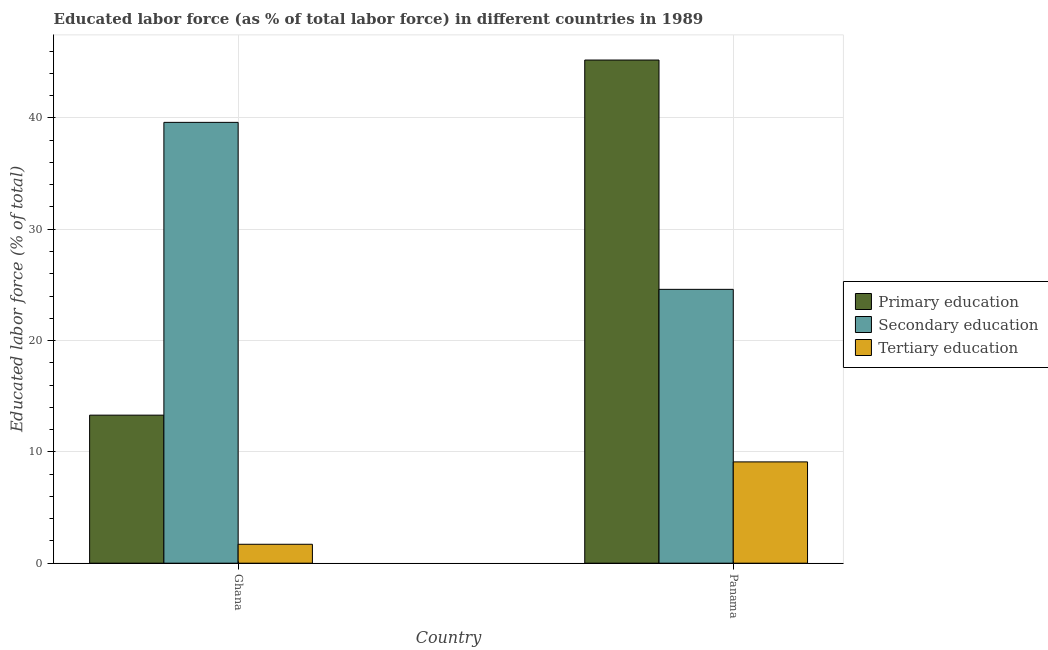How many bars are there on the 2nd tick from the right?
Give a very brief answer. 3. What is the label of the 2nd group of bars from the left?
Keep it short and to the point. Panama. In how many cases, is the number of bars for a given country not equal to the number of legend labels?
Your answer should be very brief. 0. What is the percentage of labor force who received primary education in Ghana?
Provide a short and direct response. 13.3. Across all countries, what is the maximum percentage of labor force who received primary education?
Your response must be concise. 45.2. Across all countries, what is the minimum percentage of labor force who received primary education?
Provide a succinct answer. 13.3. In which country was the percentage of labor force who received secondary education maximum?
Ensure brevity in your answer.  Ghana. In which country was the percentage of labor force who received tertiary education minimum?
Offer a terse response. Ghana. What is the total percentage of labor force who received tertiary education in the graph?
Make the answer very short. 10.8. What is the difference between the percentage of labor force who received tertiary education in Ghana and that in Panama?
Provide a short and direct response. -7.4. What is the difference between the percentage of labor force who received secondary education in Ghana and the percentage of labor force who received tertiary education in Panama?
Provide a short and direct response. 30.5. What is the average percentage of labor force who received tertiary education per country?
Provide a succinct answer. 5.4. What is the difference between the percentage of labor force who received secondary education and percentage of labor force who received tertiary education in Panama?
Give a very brief answer. 15.5. In how many countries, is the percentage of labor force who received primary education greater than 28 %?
Ensure brevity in your answer.  1. What is the ratio of the percentage of labor force who received tertiary education in Ghana to that in Panama?
Give a very brief answer. 0.19. What does the 3rd bar from the left in Ghana represents?
Provide a short and direct response. Tertiary education. How many bars are there?
Provide a succinct answer. 6. Are all the bars in the graph horizontal?
Your response must be concise. No. Are the values on the major ticks of Y-axis written in scientific E-notation?
Your answer should be compact. No. Does the graph contain any zero values?
Offer a very short reply. No. Does the graph contain grids?
Offer a very short reply. Yes. Where does the legend appear in the graph?
Offer a terse response. Center right. How many legend labels are there?
Keep it short and to the point. 3. What is the title of the graph?
Keep it short and to the point. Educated labor force (as % of total labor force) in different countries in 1989. What is the label or title of the Y-axis?
Your answer should be very brief. Educated labor force (% of total). What is the Educated labor force (% of total) of Primary education in Ghana?
Give a very brief answer. 13.3. What is the Educated labor force (% of total) of Secondary education in Ghana?
Offer a very short reply. 39.6. What is the Educated labor force (% of total) of Tertiary education in Ghana?
Make the answer very short. 1.7. What is the Educated labor force (% of total) of Primary education in Panama?
Make the answer very short. 45.2. What is the Educated labor force (% of total) of Secondary education in Panama?
Make the answer very short. 24.6. What is the Educated labor force (% of total) of Tertiary education in Panama?
Provide a short and direct response. 9.1. Across all countries, what is the maximum Educated labor force (% of total) in Primary education?
Provide a short and direct response. 45.2. Across all countries, what is the maximum Educated labor force (% of total) of Secondary education?
Provide a short and direct response. 39.6. Across all countries, what is the maximum Educated labor force (% of total) in Tertiary education?
Provide a succinct answer. 9.1. Across all countries, what is the minimum Educated labor force (% of total) in Primary education?
Make the answer very short. 13.3. Across all countries, what is the minimum Educated labor force (% of total) in Secondary education?
Offer a terse response. 24.6. Across all countries, what is the minimum Educated labor force (% of total) in Tertiary education?
Give a very brief answer. 1.7. What is the total Educated labor force (% of total) in Primary education in the graph?
Offer a terse response. 58.5. What is the total Educated labor force (% of total) of Secondary education in the graph?
Your answer should be compact. 64.2. What is the total Educated labor force (% of total) of Tertiary education in the graph?
Give a very brief answer. 10.8. What is the difference between the Educated labor force (% of total) in Primary education in Ghana and that in Panama?
Offer a terse response. -31.9. What is the difference between the Educated labor force (% of total) of Secondary education in Ghana and that in Panama?
Keep it short and to the point. 15. What is the difference between the Educated labor force (% of total) of Tertiary education in Ghana and that in Panama?
Your answer should be very brief. -7.4. What is the difference between the Educated labor force (% of total) of Primary education in Ghana and the Educated labor force (% of total) of Tertiary education in Panama?
Provide a succinct answer. 4.2. What is the difference between the Educated labor force (% of total) in Secondary education in Ghana and the Educated labor force (% of total) in Tertiary education in Panama?
Your answer should be very brief. 30.5. What is the average Educated labor force (% of total) in Primary education per country?
Ensure brevity in your answer.  29.25. What is the average Educated labor force (% of total) of Secondary education per country?
Give a very brief answer. 32.1. What is the average Educated labor force (% of total) of Tertiary education per country?
Your answer should be very brief. 5.4. What is the difference between the Educated labor force (% of total) in Primary education and Educated labor force (% of total) in Secondary education in Ghana?
Provide a short and direct response. -26.3. What is the difference between the Educated labor force (% of total) in Primary education and Educated labor force (% of total) in Tertiary education in Ghana?
Your response must be concise. 11.6. What is the difference between the Educated labor force (% of total) in Secondary education and Educated labor force (% of total) in Tertiary education in Ghana?
Offer a terse response. 37.9. What is the difference between the Educated labor force (% of total) of Primary education and Educated labor force (% of total) of Secondary education in Panama?
Make the answer very short. 20.6. What is the difference between the Educated labor force (% of total) in Primary education and Educated labor force (% of total) in Tertiary education in Panama?
Make the answer very short. 36.1. What is the ratio of the Educated labor force (% of total) of Primary education in Ghana to that in Panama?
Your answer should be very brief. 0.29. What is the ratio of the Educated labor force (% of total) of Secondary education in Ghana to that in Panama?
Provide a short and direct response. 1.61. What is the ratio of the Educated labor force (% of total) in Tertiary education in Ghana to that in Panama?
Make the answer very short. 0.19. What is the difference between the highest and the second highest Educated labor force (% of total) of Primary education?
Keep it short and to the point. 31.9. What is the difference between the highest and the lowest Educated labor force (% of total) of Primary education?
Provide a succinct answer. 31.9. What is the difference between the highest and the lowest Educated labor force (% of total) of Tertiary education?
Your answer should be compact. 7.4. 